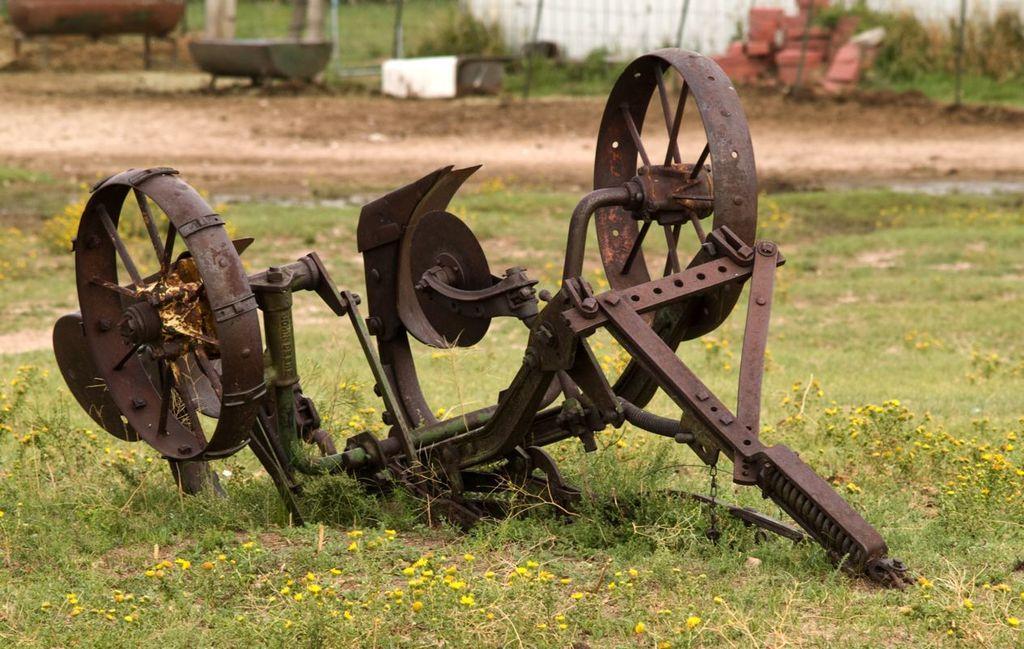How would you summarize this image in a sentence or two? In the image we can see an iron object, grass, fence, bricks and soil. 